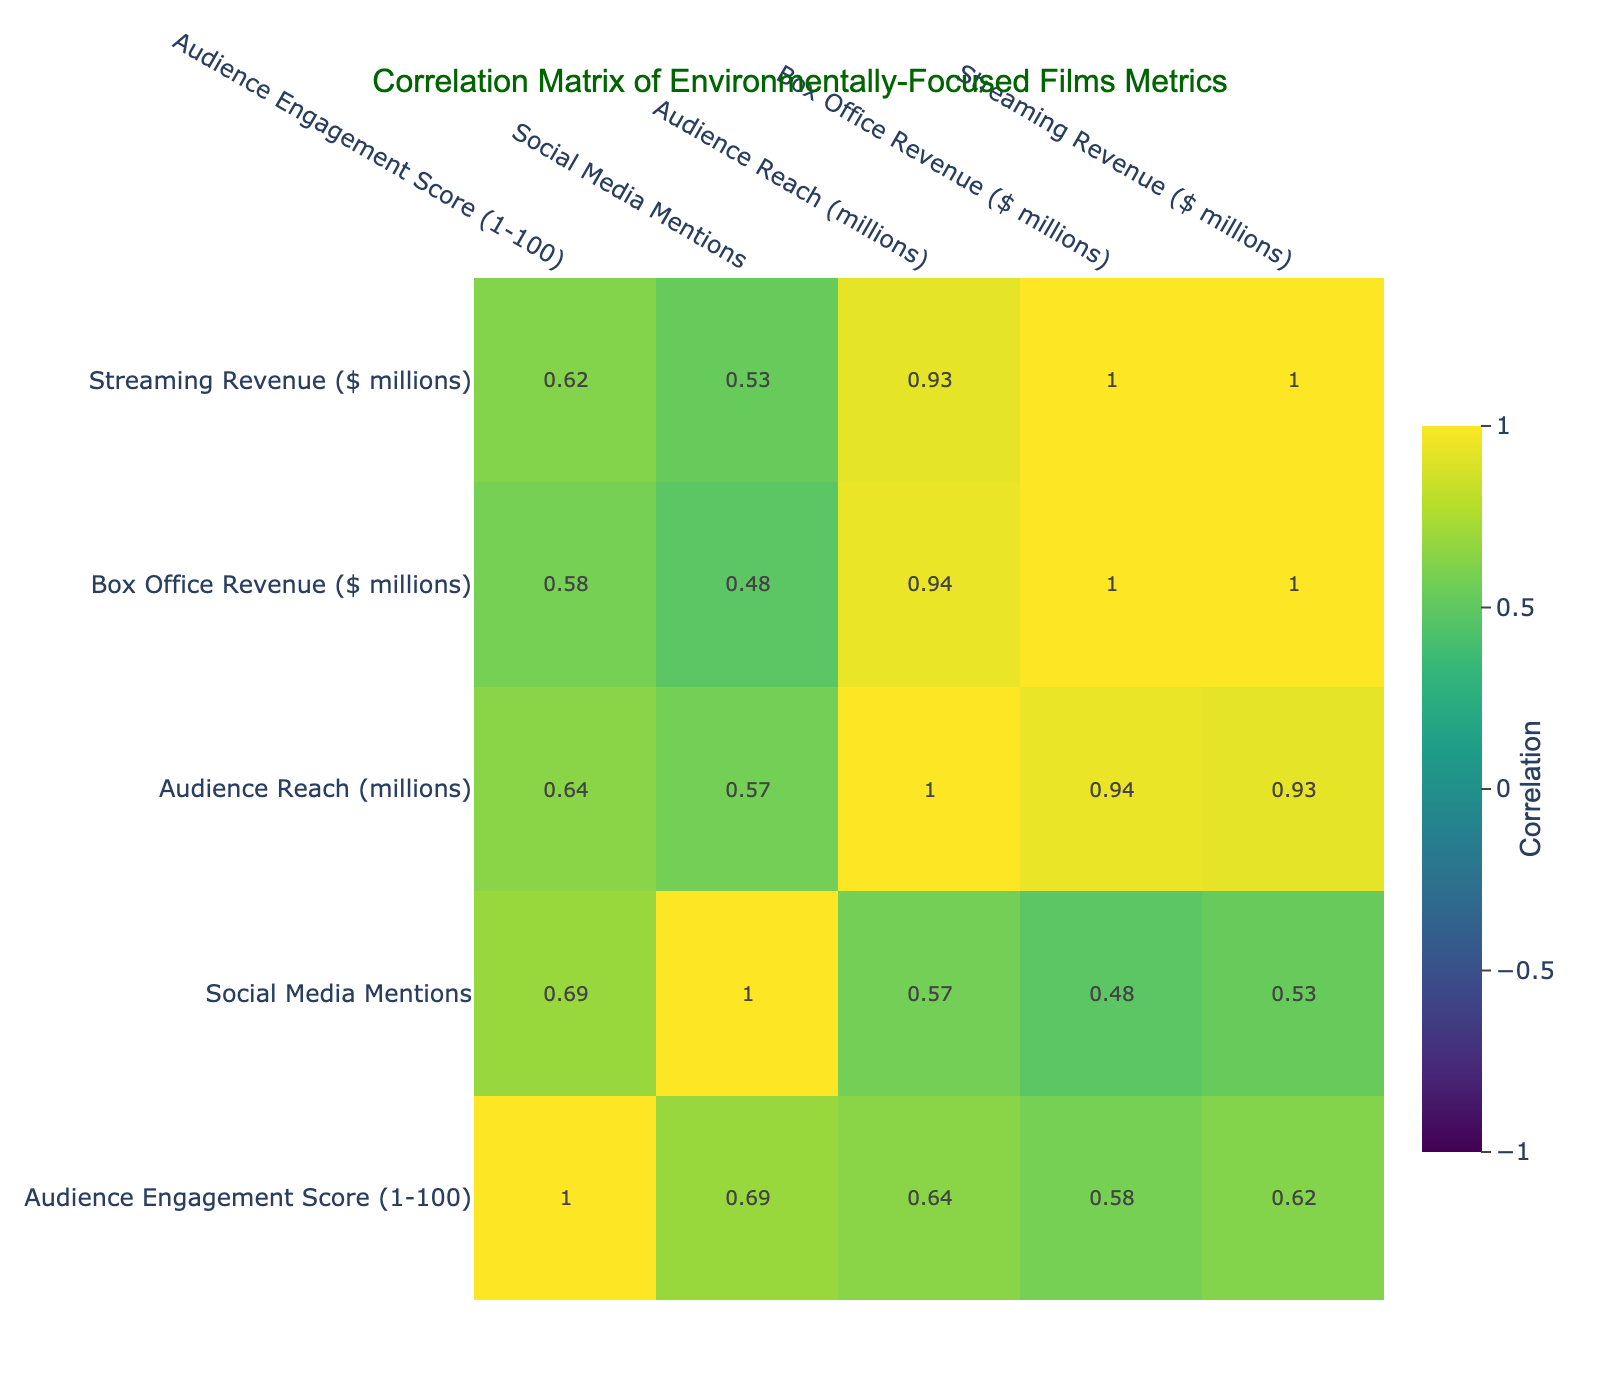What is the Audience Engagement Score of "Planet Earth II"? The Audience Engagement Score for "Planet Earth II" is listed directly in the table under the corresponding column. It can be found in the row for that film.
Answer: 95 Which film generated the highest Box Office Revenue? By examining the Box Office Revenue column, "Planet Earth II" has the highest value at 45.3 million.
Answer: "Planet Earth II" What is the average Audience Reach of the films listed? To find the average, first sum the Audience Reach values: (8 + 5 + 10 + 7 + 4 + 15 + 6 + 3 + 9 + 2) = 69. There are 10 films, so the average is 69 / 10 = 6.9 million.
Answer: 6.9 million Does "Chasing Ice" have a higher Audience Engagement Score than "Before the Flood"? Comparing the Audience Engagement Scores for the two films directly from the table shows that "Chasing Ice" has a score of 90, while "Before the Flood" has a score of 85. Since 90 > 85, the answer is yes.
Answer: Yes If we consider only the films with an Audience Engagement Score greater than 80, what is the total Streaming Revenue generated by those films? First, identify the films with scores greater than 80: "Chasing Ice" (10.0), "An Inconvenient Sequel" (5.5), "Planet Earth II" (25.0), "Years of Living Dangerously" (7.2), and "Mission: Greening" (9.0). Summing these values: 10.0 + 5.5 + 25.0 + 7.2 + 9.0 = 56.7 million.
Answer: 56.7 million Which film had the least Social Media Mentions? Looking at the Social Media Mentions column, "VeggieTales: The Wonderful Wizard of Ha's" has the least with only 5000 mentions.
Answer: "VeggieTales: The Wonderful Wizard of Ha's" Is there a correlation between Audience Engagement Score and Box Office Revenue? The correlation can be derived directly from the correlation matrix in the table. If the correlation value (which can be looked up in the matrix) indicates a positive or negative relationship, that will determine if there is correlation. For example, if the value is above 0.5, it suggests a strong positive correlation.
Answer: (Based on the required analysis, the answer would depend on the matrix outcome.) What is the difference in Box Office Revenue between the film with the highest and the film with the lowest revenue? The film with the highest revenue is "Planet Earth II" at 45.3 million, while the lowest is "VeggieTales: The Wonderful Wizard of Ha's" at 3.0 million. The difference is 45.3 - 3.0 = 42.3 million.
Answer: 42.3 million 